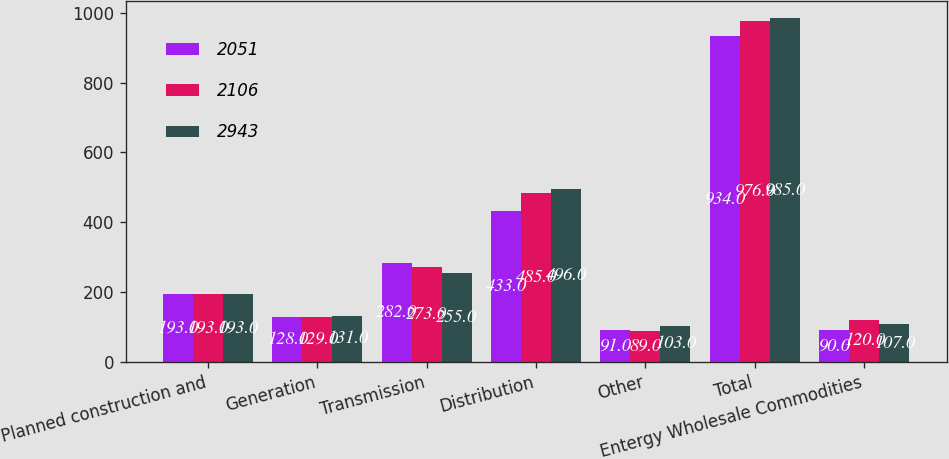<chart> <loc_0><loc_0><loc_500><loc_500><stacked_bar_chart><ecel><fcel>Planned construction and<fcel>Generation<fcel>Transmission<fcel>Distribution<fcel>Other<fcel>Total<fcel>Entergy Wholesale Commodities<nl><fcel>2051<fcel>193<fcel>128<fcel>282<fcel>433<fcel>91<fcel>934<fcel>90<nl><fcel>2106<fcel>193<fcel>129<fcel>273<fcel>485<fcel>89<fcel>976<fcel>120<nl><fcel>2943<fcel>193<fcel>131<fcel>255<fcel>496<fcel>103<fcel>985<fcel>107<nl></chart> 